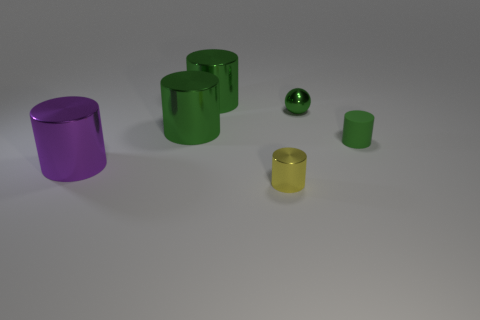Is the color of the tiny object that is behind the tiny green cylinder the same as the small metal cylinder?
Your answer should be compact. No. How many cylinders are either purple objects or green rubber objects?
Your answer should be very brief. 2. There is a yellow thing that is in front of the big object behind the green ball that is behind the small matte cylinder; how big is it?
Provide a succinct answer. Small. The metal object that is the same size as the yellow shiny cylinder is what shape?
Provide a short and direct response. Sphere. What shape is the small yellow metallic thing?
Your answer should be compact. Cylinder. Does the small object in front of the big purple shiny cylinder have the same material as the purple thing?
Your answer should be compact. Yes. What size is the green thing that is to the right of the small metallic object behind the large purple metallic thing?
Your answer should be compact. Small. What color is the small object that is both left of the tiny green matte cylinder and in front of the small green metal ball?
Give a very brief answer. Yellow. What material is the other cylinder that is the same size as the yellow cylinder?
Offer a terse response. Rubber. How many other things are there of the same material as the small green cylinder?
Ensure brevity in your answer.  0. 